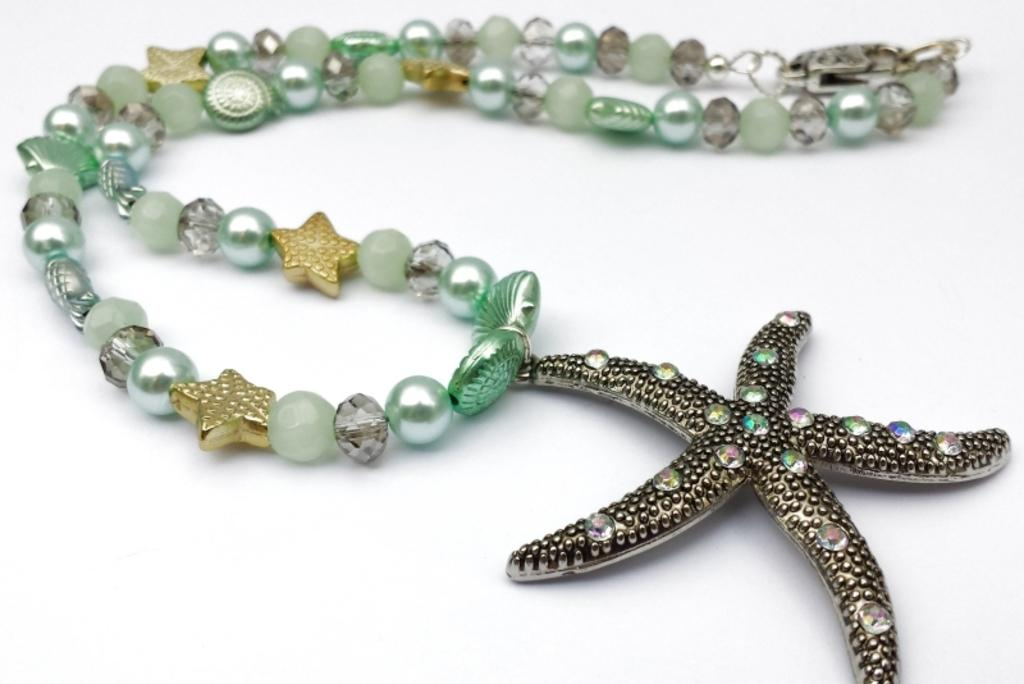What type of accessory is featured in the image? There is a bracelet in the image. What design can be seen on the bracelet? The bracelet is in the shape of stars. What type of drink is being served in the image? There is no drink present in the image; it only features a bracelet. What type of book can be seen on the table in the image? There is no book present in the image; it only features a bracelet. 